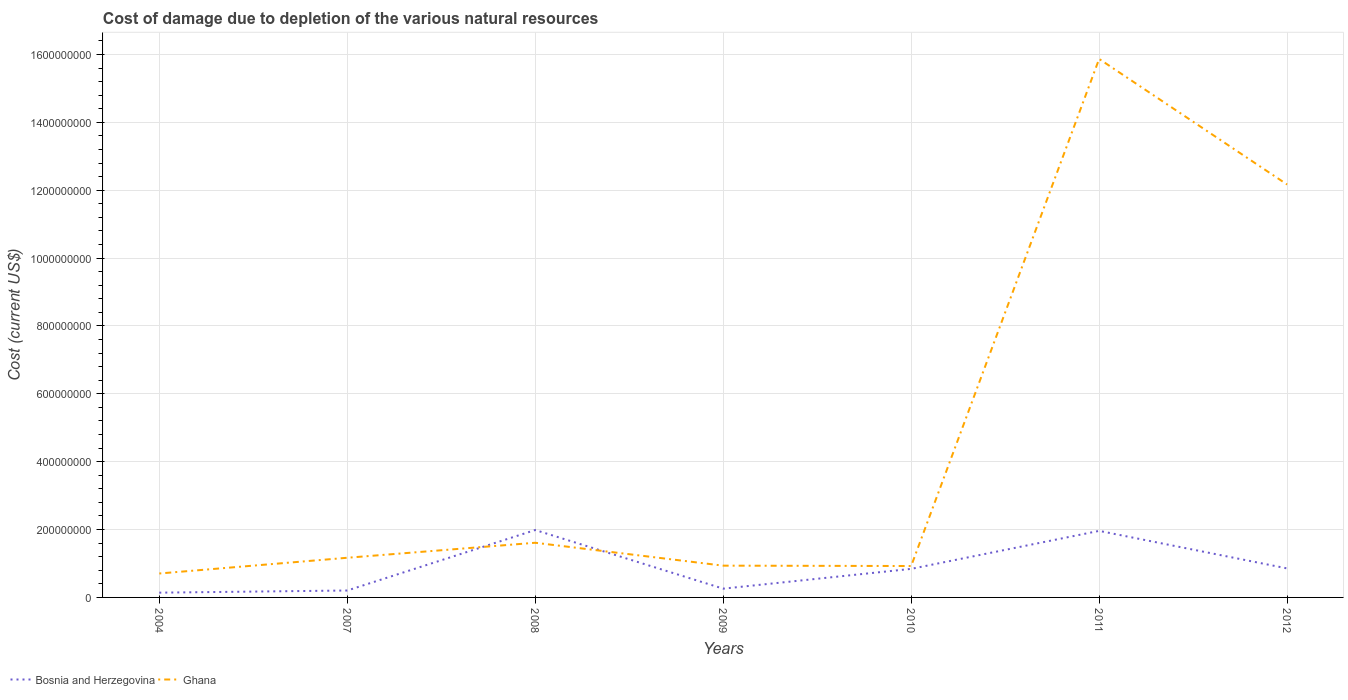Does the line corresponding to Bosnia and Herzegovina intersect with the line corresponding to Ghana?
Make the answer very short. Yes. Across all years, what is the maximum cost of damage caused due to the depletion of various natural resources in Bosnia and Herzegovina?
Provide a succinct answer. 1.40e+07. What is the total cost of damage caused due to the depletion of various natural resources in Bosnia and Herzegovina in the graph?
Your answer should be compact. 1.13e+08. What is the difference between the highest and the second highest cost of damage caused due to the depletion of various natural resources in Bosnia and Herzegovina?
Provide a short and direct response. 1.85e+08. What is the difference between the highest and the lowest cost of damage caused due to the depletion of various natural resources in Ghana?
Offer a terse response. 2. How many lines are there?
Provide a short and direct response. 2. How many years are there in the graph?
Your answer should be very brief. 7. What is the difference between two consecutive major ticks on the Y-axis?
Ensure brevity in your answer.  2.00e+08. Where does the legend appear in the graph?
Offer a terse response. Bottom left. How many legend labels are there?
Give a very brief answer. 2. How are the legend labels stacked?
Offer a very short reply. Horizontal. What is the title of the graph?
Provide a succinct answer. Cost of damage due to depletion of the various natural resources. What is the label or title of the X-axis?
Keep it short and to the point. Years. What is the label or title of the Y-axis?
Make the answer very short. Cost (current US$). What is the Cost (current US$) of Bosnia and Herzegovina in 2004?
Keep it short and to the point. 1.40e+07. What is the Cost (current US$) of Ghana in 2004?
Your answer should be very brief. 7.05e+07. What is the Cost (current US$) of Bosnia and Herzegovina in 2007?
Keep it short and to the point. 2.04e+07. What is the Cost (current US$) of Ghana in 2007?
Provide a succinct answer. 1.17e+08. What is the Cost (current US$) of Bosnia and Herzegovina in 2008?
Your answer should be compact. 1.99e+08. What is the Cost (current US$) in Ghana in 2008?
Your answer should be very brief. 1.61e+08. What is the Cost (current US$) of Bosnia and Herzegovina in 2009?
Provide a succinct answer. 2.58e+07. What is the Cost (current US$) of Ghana in 2009?
Ensure brevity in your answer.  9.36e+07. What is the Cost (current US$) of Bosnia and Herzegovina in 2010?
Offer a very short reply. 8.42e+07. What is the Cost (current US$) of Ghana in 2010?
Your response must be concise. 9.26e+07. What is the Cost (current US$) of Bosnia and Herzegovina in 2011?
Your answer should be very brief. 1.96e+08. What is the Cost (current US$) of Ghana in 2011?
Offer a very short reply. 1.59e+09. What is the Cost (current US$) of Bosnia and Herzegovina in 2012?
Your response must be concise. 8.55e+07. What is the Cost (current US$) in Ghana in 2012?
Give a very brief answer. 1.22e+09. Across all years, what is the maximum Cost (current US$) of Bosnia and Herzegovina?
Keep it short and to the point. 1.99e+08. Across all years, what is the maximum Cost (current US$) of Ghana?
Your answer should be compact. 1.59e+09. Across all years, what is the minimum Cost (current US$) of Bosnia and Herzegovina?
Keep it short and to the point. 1.40e+07. Across all years, what is the minimum Cost (current US$) of Ghana?
Keep it short and to the point. 7.05e+07. What is the total Cost (current US$) of Bosnia and Herzegovina in the graph?
Your response must be concise. 6.25e+08. What is the total Cost (current US$) of Ghana in the graph?
Your response must be concise. 3.34e+09. What is the difference between the Cost (current US$) of Bosnia and Herzegovina in 2004 and that in 2007?
Your answer should be compact. -6.36e+06. What is the difference between the Cost (current US$) of Ghana in 2004 and that in 2007?
Make the answer very short. -4.64e+07. What is the difference between the Cost (current US$) in Bosnia and Herzegovina in 2004 and that in 2008?
Provide a short and direct response. -1.85e+08. What is the difference between the Cost (current US$) of Ghana in 2004 and that in 2008?
Ensure brevity in your answer.  -9.06e+07. What is the difference between the Cost (current US$) of Bosnia and Herzegovina in 2004 and that in 2009?
Make the answer very short. -1.18e+07. What is the difference between the Cost (current US$) in Ghana in 2004 and that in 2009?
Offer a very short reply. -2.31e+07. What is the difference between the Cost (current US$) in Bosnia and Herzegovina in 2004 and that in 2010?
Provide a short and direct response. -7.01e+07. What is the difference between the Cost (current US$) in Ghana in 2004 and that in 2010?
Make the answer very short. -2.20e+07. What is the difference between the Cost (current US$) in Bosnia and Herzegovina in 2004 and that in 2011?
Your response must be concise. -1.82e+08. What is the difference between the Cost (current US$) in Ghana in 2004 and that in 2011?
Offer a very short reply. -1.52e+09. What is the difference between the Cost (current US$) in Bosnia and Herzegovina in 2004 and that in 2012?
Ensure brevity in your answer.  -7.15e+07. What is the difference between the Cost (current US$) of Ghana in 2004 and that in 2012?
Ensure brevity in your answer.  -1.15e+09. What is the difference between the Cost (current US$) of Bosnia and Herzegovina in 2007 and that in 2008?
Offer a terse response. -1.78e+08. What is the difference between the Cost (current US$) in Ghana in 2007 and that in 2008?
Your answer should be compact. -4.42e+07. What is the difference between the Cost (current US$) of Bosnia and Herzegovina in 2007 and that in 2009?
Your response must be concise. -5.43e+06. What is the difference between the Cost (current US$) of Ghana in 2007 and that in 2009?
Provide a succinct answer. 2.33e+07. What is the difference between the Cost (current US$) of Bosnia and Herzegovina in 2007 and that in 2010?
Make the answer very short. -6.38e+07. What is the difference between the Cost (current US$) of Ghana in 2007 and that in 2010?
Keep it short and to the point. 2.43e+07. What is the difference between the Cost (current US$) in Bosnia and Herzegovina in 2007 and that in 2011?
Give a very brief answer. -1.76e+08. What is the difference between the Cost (current US$) in Ghana in 2007 and that in 2011?
Your answer should be compact. -1.47e+09. What is the difference between the Cost (current US$) in Bosnia and Herzegovina in 2007 and that in 2012?
Make the answer very short. -6.51e+07. What is the difference between the Cost (current US$) of Ghana in 2007 and that in 2012?
Make the answer very short. -1.10e+09. What is the difference between the Cost (current US$) of Bosnia and Herzegovina in 2008 and that in 2009?
Keep it short and to the point. 1.73e+08. What is the difference between the Cost (current US$) in Ghana in 2008 and that in 2009?
Provide a succinct answer. 6.75e+07. What is the difference between the Cost (current US$) in Bosnia and Herzegovina in 2008 and that in 2010?
Offer a very short reply. 1.14e+08. What is the difference between the Cost (current US$) of Ghana in 2008 and that in 2010?
Offer a very short reply. 6.85e+07. What is the difference between the Cost (current US$) of Bosnia and Herzegovina in 2008 and that in 2011?
Ensure brevity in your answer.  2.52e+06. What is the difference between the Cost (current US$) in Ghana in 2008 and that in 2011?
Offer a very short reply. -1.43e+09. What is the difference between the Cost (current US$) in Bosnia and Herzegovina in 2008 and that in 2012?
Provide a succinct answer. 1.13e+08. What is the difference between the Cost (current US$) in Ghana in 2008 and that in 2012?
Offer a very short reply. -1.06e+09. What is the difference between the Cost (current US$) of Bosnia and Herzegovina in 2009 and that in 2010?
Your response must be concise. -5.83e+07. What is the difference between the Cost (current US$) in Ghana in 2009 and that in 2010?
Your answer should be compact. 1.07e+06. What is the difference between the Cost (current US$) in Bosnia and Herzegovina in 2009 and that in 2011?
Make the answer very short. -1.70e+08. What is the difference between the Cost (current US$) of Ghana in 2009 and that in 2011?
Your response must be concise. -1.49e+09. What is the difference between the Cost (current US$) of Bosnia and Herzegovina in 2009 and that in 2012?
Your answer should be compact. -5.97e+07. What is the difference between the Cost (current US$) in Ghana in 2009 and that in 2012?
Your answer should be compact. -1.12e+09. What is the difference between the Cost (current US$) of Bosnia and Herzegovina in 2010 and that in 2011?
Offer a terse response. -1.12e+08. What is the difference between the Cost (current US$) of Ghana in 2010 and that in 2011?
Your response must be concise. -1.49e+09. What is the difference between the Cost (current US$) in Bosnia and Herzegovina in 2010 and that in 2012?
Your response must be concise. -1.36e+06. What is the difference between the Cost (current US$) of Ghana in 2010 and that in 2012?
Make the answer very short. -1.12e+09. What is the difference between the Cost (current US$) of Bosnia and Herzegovina in 2011 and that in 2012?
Offer a terse response. 1.11e+08. What is the difference between the Cost (current US$) in Ghana in 2011 and that in 2012?
Provide a short and direct response. 3.70e+08. What is the difference between the Cost (current US$) in Bosnia and Herzegovina in 2004 and the Cost (current US$) in Ghana in 2007?
Provide a short and direct response. -1.03e+08. What is the difference between the Cost (current US$) of Bosnia and Herzegovina in 2004 and the Cost (current US$) of Ghana in 2008?
Give a very brief answer. -1.47e+08. What is the difference between the Cost (current US$) of Bosnia and Herzegovina in 2004 and the Cost (current US$) of Ghana in 2009?
Your response must be concise. -7.96e+07. What is the difference between the Cost (current US$) of Bosnia and Herzegovina in 2004 and the Cost (current US$) of Ghana in 2010?
Your answer should be very brief. -7.85e+07. What is the difference between the Cost (current US$) in Bosnia and Herzegovina in 2004 and the Cost (current US$) in Ghana in 2011?
Provide a short and direct response. -1.57e+09. What is the difference between the Cost (current US$) in Bosnia and Herzegovina in 2004 and the Cost (current US$) in Ghana in 2012?
Ensure brevity in your answer.  -1.20e+09. What is the difference between the Cost (current US$) of Bosnia and Herzegovina in 2007 and the Cost (current US$) of Ghana in 2008?
Make the answer very short. -1.41e+08. What is the difference between the Cost (current US$) in Bosnia and Herzegovina in 2007 and the Cost (current US$) in Ghana in 2009?
Keep it short and to the point. -7.32e+07. What is the difference between the Cost (current US$) in Bosnia and Herzegovina in 2007 and the Cost (current US$) in Ghana in 2010?
Make the answer very short. -7.22e+07. What is the difference between the Cost (current US$) in Bosnia and Herzegovina in 2007 and the Cost (current US$) in Ghana in 2011?
Make the answer very short. -1.57e+09. What is the difference between the Cost (current US$) in Bosnia and Herzegovina in 2007 and the Cost (current US$) in Ghana in 2012?
Ensure brevity in your answer.  -1.20e+09. What is the difference between the Cost (current US$) in Bosnia and Herzegovina in 2008 and the Cost (current US$) in Ghana in 2009?
Offer a terse response. 1.05e+08. What is the difference between the Cost (current US$) in Bosnia and Herzegovina in 2008 and the Cost (current US$) in Ghana in 2010?
Your answer should be very brief. 1.06e+08. What is the difference between the Cost (current US$) in Bosnia and Herzegovina in 2008 and the Cost (current US$) in Ghana in 2011?
Provide a succinct answer. -1.39e+09. What is the difference between the Cost (current US$) in Bosnia and Herzegovina in 2008 and the Cost (current US$) in Ghana in 2012?
Provide a succinct answer. -1.02e+09. What is the difference between the Cost (current US$) in Bosnia and Herzegovina in 2009 and the Cost (current US$) in Ghana in 2010?
Keep it short and to the point. -6.67e+07. What is the difference between the Cost (current US$) in Bosnia and Herzegovina in 2009 and the Cost (current US$) in Ghana in 2011?
Offer a very short reply. -1.56e+09. What is the difference between the Cost (current US$) in Bosnia and Herzegovina in 2009 and the Cost (current US$) in Ghana in 2012?
Your answer should be compact. -1.19e+09. What is the difference between the Cost (current US$) of Bosnia and Herzegovina in 2010 and the Cost (current US$) of Ghana in 2011?
Offer a terse response. -1.50e+09. What is the difference between the Cost (current US$) of Bosnia and Herzegovina in 2010 and the Cost (current US$) of Ghana in 2012?
Provide a short and direct response. -1.13e+09. What is the difference between the Cost (current US$) in Bosnia and Herzegovina in 2011 and the Cost (current US$) in Ghana in 2012?
Your answer should be very brief. -1.02e+09. What is the average Cost (current US$) in Bosnia and Herzegovina per year?
Your response must be concise. 8.93e+07. What is the average Cost (current US$) in Ghana per year?
Your response must be concise. 4.77e+08. In the year 2004, what is the difference between the Cost (current US$) of Bosnia and Herzegovina and Cost (current US$) of Ghana?
Give a very brief answer. -5.65e+07. In the year 2007, what is the difference between the Cost (current US$) of Bosnia and Herzegovina and Cost (current US$) of Ghana?
Provide a succinct answer. -9.65e+07. In the year 2008, what is the difference between the Cost (current US$) of Bosnia and Herzegovina and Cost (current US$) of Ghana?
Make the answer very short. 3.75e+07. In the year 2009, what is the difference between the Cost (current US$) in Bosnia and Herzegovina and Cost (current US$) in Ghana?
Ensure brevity in your answer.  -6.78e+07. In the year 2010, what is the difference between the Cost (current US$) of Bosnia and Herzegovina and Cost (current US$) of Ghana?
Keep it short and to the point. -8.41e+06. In the year 2011, what is the difference between the Cost (current US$) in Bosnia and Herzegovina and Cost (current US$) in Ghana?
Give a very brief answer. -1.39e+09. In the year 2012, what is the difference between the Cost (current US$) of Bosnia and Herzegovina and Cost (current US$) of Ghana?
Your response must be concise. -1.13e+09. What is the ratio of the Cost (current US$) in Bosnia and Herzegovina in 2004 to that in 2007?
Offer a very short reply. 0.69. What is the ratio of the Cost (current US$) in Ghana in 2004 to that in 2007?
Your response must be concise. 0.6. What is the ratio of the Cost (current US$) of Bosnia and Herzegovina in 2004 to that in 2008?
Your answer should be compact. 0.07. What is the ratio of the Cost (current US$) in Ghana in 2004 to that in 2008?
Make the answer very short. 0.44. What is the ratio of the Cost (current US$) of Bosnia and Herzegovina in 2004 to that in 2009?
Ensure brevity in your answer.  0.54. What is the ratio of the Cost (current US$) in Ghana in 2004 to that in 2009?
Your answer should be compact. 0.75. What is the ratio of the Cost (current US$) in Bosnia and Herzegovina in 2004 to that in 2010?
Keep it short and to the point. 0.17. What is the ratio of the Cost (current US$) in Ghana in 2004 to that in 2010?
Your answer should be compact. 0.76. What is the ratio of the Cost (current US$) in Bosnia and Herzegovina in 2004 to that in 2011?
Your answer should be very brief. 0.07. What is the ratio of the Cost (current US$) in Ghana in 2004 to that in 2011?
Give a very brief answer. 0.04. What is the ratio of the Cost (current US$) of Bosnia and Herzegovina in 2004 to that in 2012?
Offer a very short reply. 0.16. What is the ratio of the Cost (current US$) in Ghana in 2004 to that in 2012?
Your response must be concise. 0.06. What is the ratio of the Cost (current US$) of Bosnia and Herzegovina in 2007 to that in 2008?
Your answer should be compact. 0.1. What is the ratio of the Cost (current US$) in Ghana in 2007 to that in 2008?
Offer a very short reply. 0.73. What is the ratio of the Cost (current US$) of Bosnia and Herzegovina in 2007 to that in 2009?
Keep it short and to the point. 0.79. What is the ratio of the Cost (current US$) of Ghana in 2007 to that in 2009?
Provide a succinct answer. 1.25. What is the ratio of the Cost (current US$) of Bosnia and Herzegovina in 2007 to that in 2010?
Offer a terse response. 0.24. What is the ratio of the Cost (current US$) of Ghana in 2007 to that in 2010?
Your response must be concise. 1.26. What is the ratio of the Cost (current US$) in Bosnia and Herzegovina in 2007 to that in 2011?
Ensure brevity in your answer.  0.1. What is the ratio of the Cost (current US$) in Ghana in 2007 to that in 2011?
Make the answer very short. 0.07. What is the ratio of the Cost (current US$) in Bosnia and Herzegovina in 2007 to that in 2012?
Keep it short and to the point. 0.24. What is the ratio of the Cost (current US$) in Ghana in 2007 to that in 2012?
Keep it short and to the point. 0.1. What is the ratio of the Cost (current US$) of Bosnia and Herzegovina in 2008 to that in 2009?
Your response must be concise. 7.69. What is the ratio of the Cost (current US$) of Ghana in 2008 to that in 2009?
Provide a short and direct response. 1.72. What is the ratio of the Cost (current US$) of Bosnia and Herzegovina in 2008 to that in 2010?
Ensure brevity in your answer.  2.36. What is the ratio of the Cost (current US$) of Ghana in 2008 to that in 2010?
Provide a short and direct response. 1.74. What is the ratio of the Cost (current US$) in Bosnia and Herzegovina in 2008 to that in 2011?
Your answer should be very brief. 1.01. What is the ratio of the Cost (current US$) of Ghana in 2008 to that in 2011?
Ensure brevity in your answer.  0.1. What is the ratio of the Cost (current US$) of Bosnia and Herzegovina in 2008 to that in 2012?
Your answer should be very brief. 2.32. What is the ratio of the Cost (current US$) of Ghana in 2008 to that in 2012?
Provide a succinct answer. 0.13. What is the ratio of the Cost (current US$) of Bosnia and Herzegovina in 2009 to that in 2010?
Provide a succinct answer. 0.31. What is the ratio of the Cost (current US$) of Ghana in 2009 to that in 2010?
Ensure brevity in your answer.  1.01. What is the ratio of the Cost (current US$) of Bosnia and Herzegovina in 2009 to that in 2011?
Ensure brevity in your answer.  0.13. What is the ratio of the Cost (current US$) in Ghana in 2009 to that in 2011?
Your answer should be very brief. 0.06. What is the ratio of the Cost (current US$) in Bosnia and Herzegovina in 2009 to that in 2012?
Keep it short and to the point. 0.3. What is the ratio of the Cost (current US$) in Ghana in 2009 to that in 2012?
Ensure brevity in your answer.  0.08. What is the ratio of the Cost (current US$) of Bosnia and Herzegovina in 2010 to that in 2011?
Keep it short and to the point. 0.43. What is the ratio of the Cost (current US$) in Ghana in 2010 to that in 2011?
Make the answer very short. 0.06. What is the ratio of the Cost (current US$) in Bosnia and Herzegovina in 2010 to that in 2012?
Offer a very short reply. 0.98. What is the ratio of the Cost (current US$) of Ghana in 2010 to that in 2012?
Make the answer very short. 0.08. What is the ratio of the Cost (current US$) in Bosnia and Herzegovina in 2011 to that in 2012?
Provide a short and direct response. 2.29. What is the ratio of the Cost (current US$) of Ghana in 2011 to that in 2012?
Make the answer very short. 1.3. What is the difference between the highest and the second highest Cost (current US$) in Bosnia and Herzegovina?
Provide a succinct answer. 2.52e+06. What is the difference between the highest and the second highest Cost (current US$) of Ghana?
Ensure brevity in your answer.  3.70e+08. What is the difference between the highest and the lowest Cost (current US$) of Bosnia and Herzegovina?
Provide a succinct answer. 1.85e+08. What is the difference between the highest and the lowest Cost (current US$) of Ghana?
Your answer should be very brief. 1.52e+09. 